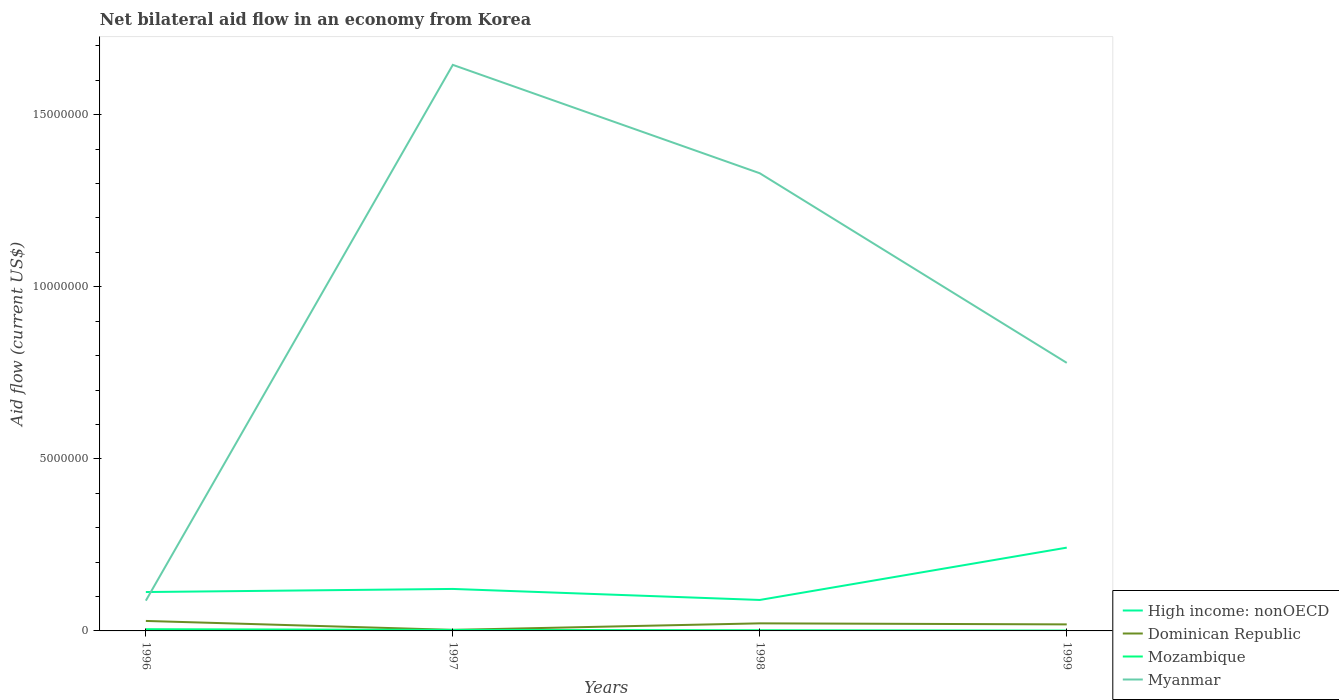How many different coloured lines are there?
Provide a short and direct response. 4. Does the line corresponding to Mozambique intersect with the line corresponding to Dominican Republic?
Offer a very short reply. Yes. Across all years, what is the maximum net bilateral aid flow in Myanmar?
Your response must be concise. 8.80e+05. What is the total net bilateral aid flow in High income: nonOECD in the graph?
Your answer should be compact. 2.30e+05. What is the difference between the highest and the second highest net bilateral aid flow in High income: nonOECD?
Provide a succinct answer. 1.52e+06. Are the values on the major ticks of Y-axis written in scientific E-notation?
Give a very brief answer. No. Does the graph contain any zero values?
Offer a terse response. No. Where does the legend appear in the graph?
Your answer should be very brief. Bottom right. How are the legend labels stacked?
Provide a succinct answer. Vertical. What is the title of the graph?
Make the answer very short. Net bilateral aid flow in an economy from Korea. Does "Luxembourg" appear as one of the legend labels in the graph?
Ensure brevity in your answer.  No. What is the label or title of the Y-axis?
Your answer should be compact. Aid flow (current US$). What is the Aid flow (current US$) of High income: nonOECD in 1996?
Provide a succinct answer. 1.13e+06. What is the Aid flow (current US$) of Dominican Republic in 1996?
Your answer should be compact. 2.90e+05. What is the Aid flow (current US$) of Myanmar in 1996?
Provide a short and direct response. 8.80e+05. What is the Aid flow (current US$) of High income: nonOECD in 1997?
Your answer should be very brief. 1.22e+06. What is the Aid flow (current US$) of Mozambique in 1997?
Provide a short and direct response. 3.00e+04. What is the Aid flow (current US$) of Myanmar in 1997?
Your answer should be very brief. 1.64e+07. What is the Aid flow (current US$) in Dominican Republic in 1998?
Keep it short and to the point. 2.20e+05. What is the Aid flow (current US$) in Myanmar in 1998?
Provide a succinct answer. 1.33e+07. What is the Aid flow (current US$) of High income: nonOECD in 1999?
Your answer should be compact. 2.42e+06. What is the Aid flow (current US$) of Myanmar in 1999?
Make the answer very short. 7.79e+06. Across all years, what is the maximum Aid flow (current US$) of High income: nonOECD?
Your answer should be compact. 2.42e+06. Across all years, what is the maximum Aid flow (current US$) of Dominican Republic?
Offer a very short reply. 2.90e+05. Across all years, what is the maximum Aid flow (current US$) in Myanmar?
Give a very brief answer. 1.64e+07. Across all years, what is the minimum Aid flow (current US$) of High income: nonOECD?
Give a very brief answer. 9.00e+05. Across all years, what is the minimum Aid flow (current US$) of Dominican Republic?
Provide a succinct answer. 3.00e+04. Across all years, what is the minimum Aid flow (current US$) of Myanmar?
Provide a succinct answer. 8.80e+05. What is the total Aid flow (current US$) of High income: nonOECD in the graph?
Provide a succinct answer. 5.67e+06. What is the total Aid flow (current US$) of Dominican Republic in the graph?
Your response must be concise. 7.30e+05. What is the total Aid flow (current US$) in Myanmar in the graph?
Your answer should be very brief. 3.84e+07. What is the difference between the Aid flow (current US$) in High income: nonOECD in 1996 and that in 1997?
Provide a succinct answer. -9.00e+04. What is the difference between the Aid flow (current US$) of Mozambique in 1996 and that in 1997?
Provide a succinct answer. 2.00e+04. What is the difference between the Aid flow (current US$) in Myanmar in 1996 and that in 1997?
Give a very brief answer. -1.56e+07. What is the difference between the Aid flow (current US$) of Dominican Republic in 1996 and that in 1998?
Ensure brevity in your answer.  7.00e+04. What is the difference between the Aid flow (current US$) of Myanmar in 1996 and that in 1998?
Keep it short and to the point. -1.24e+07. What is the difference between the Aid flow (current US$) in High income: nonOECD in 1996 and that in 1999?
Keep it short and to the point. -1.29e+06. What is the difference between the Aid flow (current US$) of Myanmar in 1996 and that in 1999?
Provide a succinct answer. -6.91e+06. What is the difference between the Aid flow (current US$) in Dominican Republic in 1997 and that in 1998?
Give a very brief answer. -1.90e+05. What is the difference between the Aid flow (current US$) of Myanmar in 1997 and that in 1998?
Keep it short and to the point. 3.15e+06. What is the difference between the Aid flow (current US$) in High income: nonOECD in 1997 and that in 1999?
Offer a terse response. -1.20e+06. What is the difference between the Aid flow (current US$) in Myanmar in 1997 and that in 1999?
Give a very brief answer. 8.66e+06. What is the difference between the Aid flow (current US$) in High income: nonOECD in 1998 and that in 1999?
Keep it short and to the point. -1.52e+06. What is the difference between the Aid flow (current US$) in Myanmar in 1998 and that in 1999?
Your answer should be compact. 5.51e+06. What is the difference between the Aid flow (current US$) of High income: nonOECD in 1996 and the Aid flow (current US$) of Dominican Republic in 1997?
Keep it short and to the point. 1.10e+06. What is the difference between the Aid flow (current US$) of High income: nonOECD in 1996 and the Aid flow (current US$) of Mozambique in 1997?
Make the answer very short. 1.10e+06. What is the difference between the Aid flow (current US$) in High income: nonOECD in 1996 and the Aid flow (current US$) in Myanmar in 1997?
Make the answer very short. -1.53e+07. What is the difference between the Aid flow (current US$) in Dominican Republic in 1996 and the Aid flow (current US$) in Myanmar in 1997?
Give a very brief answer. -1.62e+07. What is the difference between the Aid flow (current US$) in Mozambique in 1996 and the Aid flow (current US$) in Myanmar in 1997?
Provide a short and direct response. -1.64e+07. What is the difference between the Aid flow (current US$) in High income: nonOECD in 1996 and the Aid flow (current US$) in Dominican Republic in 1998?
Offer a terse response. 9.10e+05. What is the difference between the Aid flow (current US$) of High income: nonOECD in 1996 and the Aid flow (current US$) of Mozambique in 1998?
Ensure brevity in your answer.  1.11e+06. What is the difference between the Aid flow (current US$) of High income: nonOECD in 1996 and the Aid flow (current US$) of Myanmar in 1998?
Your answer should be compact. -1.22e+07. What is the difference between the Aid flow (current US$) of Dominican Republic in 1996 and the Aid flow (current US$) of Mozambique in 1998?
Offer a terse response. 2.70e+05. What is the difference between the Aid flow (current US$) of Dominican Republic in 1996 and the Aid flow (current US$) of Myanmar in 1998?
Provide a succinct answer. -1.30e+07. What is the difference between the Aid flow (current US$) of Mozambique in 1996 and the Aid flow (current US$) of Myanmar in 1998?
Keep it short and to the point. -1.32e+07. What is the difference between the Aid flow (current US$) in High income: nonOECD in 1996 and the Aid flow (current US$) in Dominican Republic in 1999?
Your response must be concise. 9.40e+05. What is the difference between the Aid flow (current US$) of High income: nonOECD in 1996 and the Aid flow (current US$) of Mozambique in 1999?
Provide a succinct answer. 1.12e+06. What is the difference between the Aid flow (current US$) in High income: nonOECD in 1996 and the Aid flow (current US$) in Myanmar in 1999?
Provide a succinct answer. -6.66e+06. What is the difference between the Aid flow (current US$) of Dominican Republic in 1996 and the Aid flow (current US$) of Mozambique in 1999?
Ensure brevity in your answer.  2.80e+05. What is the difference between the Aid flow (current US$) of Dominican Republic in 1996 and the Aid flow (current US$) of Myanmar in 1999?
Make the answer very short. -7.50e+06. What is the difference between the Aid flow (current US$) of Mozambique in 1996 and the Aid flow (current US$) of Myanmar in 1999?
Your answer should be compact. -7.74e+06. What is the difference between the Aid flow (current US$) of High income: nonOECD in 1997 and the Aid flow (current US$) of Dominican Republic in 1998?
Keep it short and to the point. 1.00e+06. What is the difference between the Aid flow (current US$) of High income: nonOECD in 1997 and the Aid flow (current US$) of Mozambique in 1998?
Keep it short and to the point. 1.20e+06. What is the difference between the Aid flow (current US$) of High income: nonOECD in 1997 and the Aid flow (current US$) of Myanmar in 1998?
Keep it short and to the point. -1.21e+07. What is the difference between the Aid flow (current US$) of Dominican Republic in 1997 and the Aid flow (current US$) of Myanmar in 1998?
Ensure brevity in your answer.  -1.33e+07. What is the difference between the Aid flow (current US$) of Mozambique in 1997 and the Aid flow (current US$) of Myanmar in 1998?
Make the answer very short. -1.33e+07. What is the difference between the Aid flow (current US$) in High income: nonOECD in 1997 and the Aid flow (current US$) in Dominican Republic in 1999?
Ensure brevity in your answer.  1.03e+06. What is the difference between the Aid flow (current US$) in High income: nonOECD in 1997 and the Aid flow (current US$) in Mozambique in 1999?
Offer a terse response. 1.21e+06. What is the difference between the Aid flow (current US$) of High income: nonOECD in 1997 and the Aid flow (current US$) of Myanmar in 1999?
Your response must be concise. -6.57e+06. What is the difference between the Aid flow (current US$) of Dominican Republic in 1997 and the Aid flow (current US$) of Myanmar in 1999?
Offer a very short reply. -7.76e+06. What is the difference between the Aid flow (current US$) of Mozambique in 1997 and the Aid flow (current US$) of Myanmar in 1999?
Make the answer very short. -7.76e+06. What is the difference between the Aid flow (current US$) of High income: nonOECD in 1998 and the Aid flow (current US$) of Dominican Republic in 1999?
Your answer should be very brief. 7.10e+05. What is the difference between the Aid flow (current US$) in High income: nonOECD in 1998 and the Aid flow (current US$) in Mozambique in 1999?
Offer a very short reply. 8.90e+05. What is the difference between the Aid flow (current US$) of High income: nonOECD in 1998 and the Aid flow (current US$) of Myanmar in 1999?
Ensure brevity in your answer.  -6.89e+06. What is the difference between the Aid flow (current US$) of Dominican Republic in 1998 and the Aid flow (current US$) of Mozambique in 1999?
Your answer should be very brief. 2.10e+05. What is the difference between the Aid flow (current US$) in Dominican Republic in 1998 and the Aid flow (current US$) in Myanmar in 1999?
Ensure brevity in your answer.  -7.57e+06. What is the difference between the Aid flow (current US$) in Mozambique in 1998 and the Aid flow (current US$) in Myanmar in 1999?
Make the answer very short. -7.77e+06. What is the average Aid flow (current US$) in High income: nonOECD per year?
Ensure brevity in your answer.  1.42e+06. What is the average Aid flow (current US$) in Dominican Republic per year?
Your response must be concise. 1.82e+05. What is the average Aid flow (current US$) in Mozambique per year?
Provide a succinct answer. 2.75e+04. What is the average Aid flow (current US$) of Myanmar per year?
Your response must be concise. 9.60e+06. In the year 1996, what is the difference between the Aid flow (current US$) in High income: nonOECD and Aid flow (current US$) in Dominican Republic?
Offer a terse response. 8.40e+05. In the year 1996, what is the difference between the Aid flow (current US$) of High income: nonOECD and Aid flow (current US$) of Mozambique?
Offer a very short reply. 1.08e+06. In the year 1996, what is the difference between the Aid flow (current US$) in Dominican Republic and Aid flow (current US$) in Mozambique?
Provide a succinct answer. 2.40e+05. In the year 1996, what is the difference between the Aid flow (current US$) of Dominican Republic and Aid flow (current US$) of Myanmar?
Make the answer very short. -5.90e+05. In the year 1996, what is the difference between the Aid flow (current US$) of Mozambique and Aid flow (current US$) of Myanmar?
Give a very brief answer. -8.30e+05. In the year 1997, what is the difference between the Aid flow (current US$) of High income: nonOECD and Aid flow (current US$) of Dominican Republic?
Your answer should be compact. 1.19e+06. In the year 1997, what is the difference between the Aid flow (current US$) in High income: nonOECD and Aid flow (current US$) in Mozambique?
Provide a succinct answer. 1.19e+06. In the year 1997, what is the difference between the Aid flow (current US$) in High income: nonOECD and Aid flow (current US$) in Myanmar?
Your response must be concise. -1.52e+07. In the year 1997, what is the difference between the Aid flow (current US$) of Dominican Republic and Aid flow (current US$) of Mozambique?
Give a very brief answer. 0. In the year 1997, what is the difference between the Aid flow (current US$) of Dominican Republic and Aid flow (current US$) of Myanmar?
Your answer should be very brief. -1.64e+07. In the year 1997, what is the difference between the Aid flow (current US$) of Mozambique and Aid flow (current US$) of Myanmar?
Make the answer very short. -1.64e+07. In the year 1998, what is the difference between the Aid flow (current US$) in High income: nonOECD and Aid flow (current US$) in Dominican Republic?
Give a very brief answer. 6.80e+05. In the year 1998, what is the difference between the Aid flow (current US$) of High income: nonOECD and Aid flow (current US$) of Mozambique?
Your answer should be compact. 8.80e+05. In the year 1998, what is the difference between the Aid flow (current US$) in High income: nonOECD and Aid flow (current US$) in Myanmar?
Provide a succinct answer. -1.24e+07. In the year 1998, what is the difference between the Aid flow (current US$) in Dominican Republic and Aid flow (current US$) in Mozambique?
Keep it short and to the point. 2.00e+05. In the year 1998, what is the difference between the Aid flow (current US$) in Dominican Republic and Aid flow (current US$) in Myanmar?
Offer a very short reply. -1.31e+07. In the year 1998, what is the difference between the Aid flow (current US$) of Mozambique and Aid flow (current US$) of Myanmar?
Offer a terse response. -1.33e+07. In the year 1999, what is the difference between the Aid flow (current US$) in High income: nonOECD and Aid flow (current US$) in Dominican Republic?
Your answer should be compact. 2.23e+06. In the year 1999, what is the difference between the Aid flow (current US$) in High income: nonOECD and Aid flow (current US$) in Mozambique?
Ensure brevity in your answer.  2.41e+06. In the year 1999, what is the difference between the Aid flow (current US$) of High income: nonOECD and Aid flow (current US$) of Myanmar?
Your answer should be compact. -5.37e+06. In the year 1999, what is the difference between the Aid flow (current US$) in Dominican Republic and Aid flow (current US$) in Myanmar?
Your response must be concise. -7.60e+06. In the year 1999, what is the difference between the Aid flow (current US$) of Mozambique and Aid flow (current US$) of Myanmar?
Provide a short and direct response. -7.78e+06. What is the ratio of the Aid flow (current US$) of High income: nonOECD in 1996 to that in 1997?
Provide a short and direct response. 0.93. What is the ratio of the Aid flow (current US$) in Dominican Republic in 1996 to that in 1997?
Offer a terse response. 9.67. What is the ratio of the Aid flow (current US$) in Myanmar in 1996 to that in 1997?
Your response must be concise. 0.05. What is the ratio of the Aid flow (current US$) of High income: nonOECD in 1996 to that in 1998?
Your answer should be compact. 1.26. What is the ratio of the Aid flow (current US$) in Dominican Republic in 1996 to that in 1998?
Your answer should be compact. 1.32. What is the ratio of the Aid flow (current US$) of Myanmar in 1996 to that in 1998?
Give a very brief answer. 0.07. What is the ratio of the Aid flow (current US$) of High income: nonOECD in 1996 to that in 1999?
Make the answer very short. 0.47. What is the ratio of the Aid flow (current US$) in Dominican Republic in 1996 to that in 1999?
Keep it short and to the point. 1.53. What is the ratio of the Aid flow (current US$) of Mozambique in 1996 to that in 1999?
Your answer should be compact. 5. What is the ratio of the Aid flow (current US$) of Myanmar in 1996 to that in 1999?
Your answer should be very brief. 0.11. What is the ratio of the Aid flow (current US$) in High income: nonOECD in 1997 to that in 1998?
Provide a succinct answer. 1.36. What is the ratio of the Aid flow (current US$) of Dominican Republic in 1997 to that in 1998?
Provide a short and direct response. 0.14. What is the ratio of the Aid flow (current US$) of Myanmar in 1997 to that in 1998?
Offer a very short reply. 1.24. What is the ratio of the Aid flow (current US$) of High income: nonOECD in 1997 to that in 1999?
Offer a terse response. 0.5. What is the ratio of the Aid flow (current US$) in Dominican Republic in 1997 to that in 1999?
Offer a very short reply. 0.16. What is the ratio of the Aid flow (current US$) of Myanmar in 1997 to that in 1999?
Offer a terse response. 2.11. What is the ratio of the Aid flow (current US$) in High income: nonOECD in 1998 to that in 1999?
Make the answer very short. 0.37. What is the ratio of the Aid flow (current US$) of Dominican Republic in 1998 to that in 1999?
Provide a succinct answer. 1.16. What is the ratio of the Aid flow (current US$) of Mozambique in 1998 to that in 1999?
Provide a succinct answer. 2. What is the ratio of the Aid flow (current US$) in Myanmar in 1998 to that in 1999?
Your answer should be compact. 1.71. What is the difference between the highest and the second highest Aid flow (current US$) of High income: nonOECD?
Give a very brief answer. 1.20e+06. What is the difference between the highest and the second highest Aid flow (current US$) in Dominican Republic?
Offer a very short reply. 7.00e+04. What is the difference between the highest and the second highest Aid flow (current US$) in Mozambique?
Offer a very short reply. 2.00e+04. What is the difference between the highest and the second highest Aid flow (current US$) of Myanmar?
Your answer should be compact. 3.15e+06. What is the difference between the highest and the lowest Aid flow (current US$) in High income: nonOECD?
Give a very brief answer. 1.52e+06. What is the difference between the highest and the lowest Aid flow (current US$) in Dominican Republic?
Make the answer very short. 2.60e+05. What is the difference between the highest and the lowest Aid flow (current US$) in Mozambique?
Your answer should be compact. 4.00e+04. What is the difference between the highest and the lowest Aid flow (current US$) in Myanmar?
Ensure brevity in your answer.  1.56e+07. 